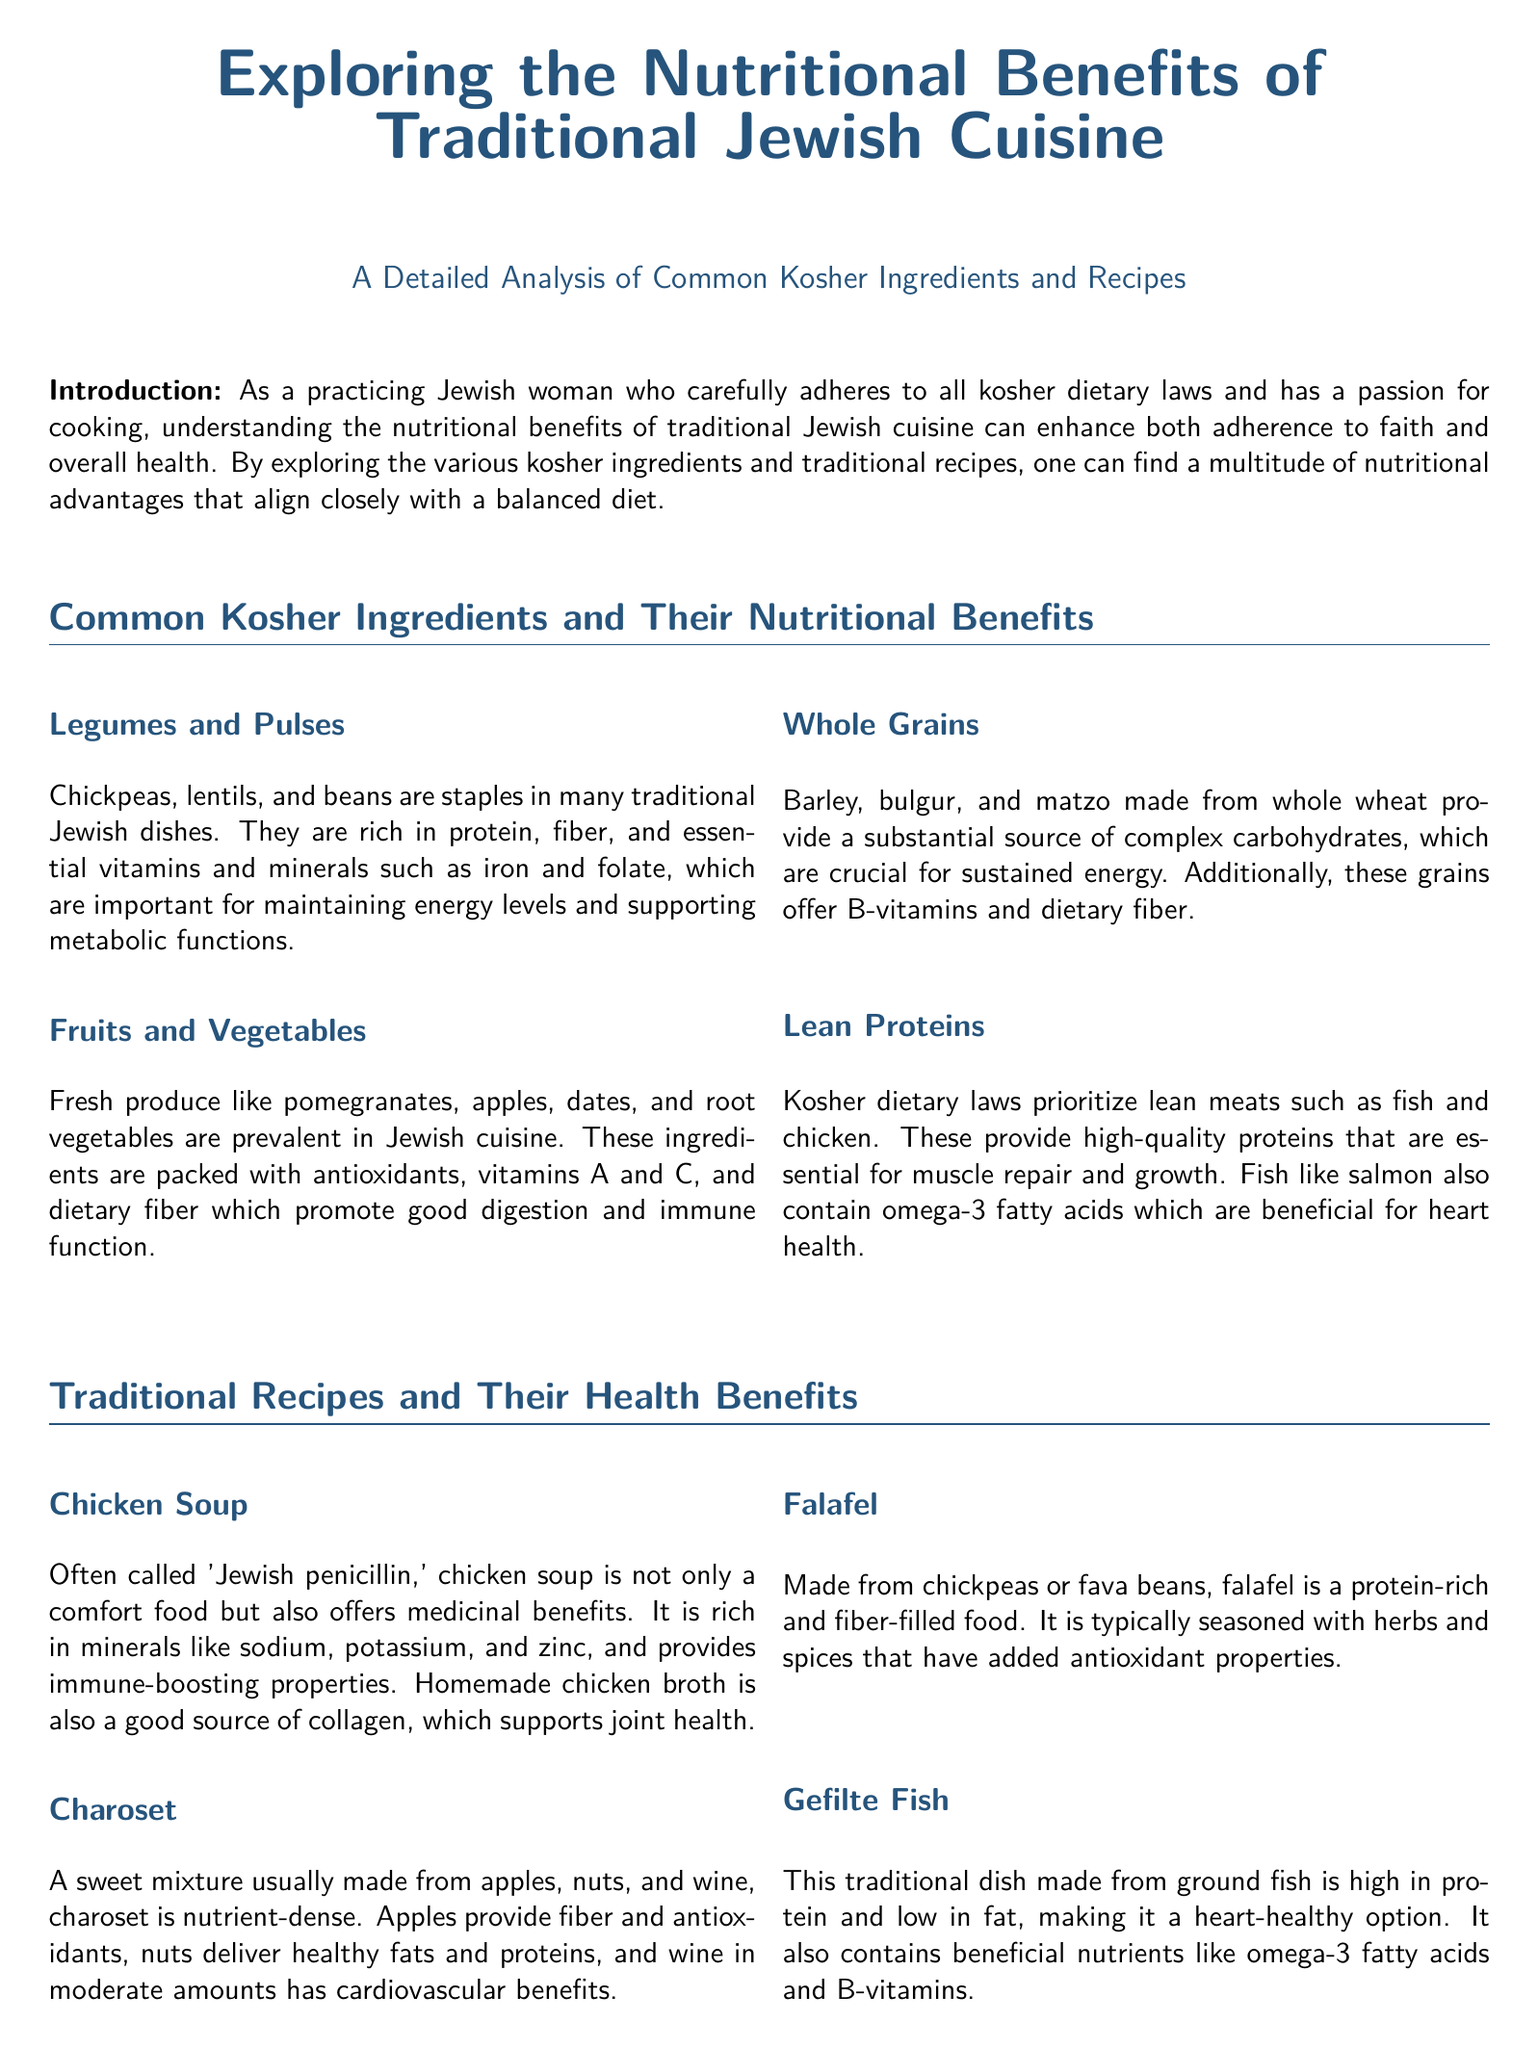What are common kosher ingredients mentioned? The document lists legumes and pulses, fruits and vegetables, whole grains, and lean proteins as common kosher ingredients.
Answer: legumes and pulses, fruits and vegetables, whole grains, lean proteins What is a primary source of dietary fiber in Jewish cuisine? The document highlights legumes, fruits, vegetables, and whole grains as important sources of dietary fiber.
Answer: legumes, fruits, vegetables, whole grains What is often referred to as 'Jewish penicillin'? The document describes chicken soup as being called 'Jewish penicillin' due to its comfort and medicinal benefits.
Answer: chicken soup How many traditional recipes are analyzed in the document? The document discusses a total of four traditional recipes: chicken soup, charoset, falafel, and gefilte fish.
Answer: four What beneficial nutrient does salmon contain? The document states that salmon contains omega-3 fatty acids, which are beneficial for heart health.
Answer: omega-3 fatty acids What is charoset primarily made from? The document mentions that charoset is usually made from apples, nuts, and wine.
Answer: apples, nuts, and wine Which ingredient in falafel contributes to its high protein content? The document indicates that falafel is primarily made from chickpeas or fava beans, which contribute to its protein content.
Answer: chickpeas or fava beans What are the antioxidant-rich ingredients in charoset? The document states that apples and nuts in charoset provide antioxidants.
Answer: apples and nuts What dietary law is discussed in relation to the ingredients? The document emphasizes adherence to kosher dietary laws throughout the analysis of ingredients and recipes.
Answer: kosher dietary laws 